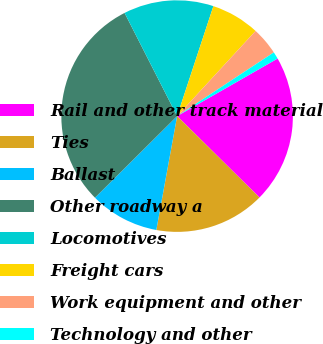<chart> <loc_0><loc_0><loc_500><loc_500><pie_chart><fcel>Rail and other track material<fcel>Ties<fcel>Ballast<fcel>Other roadway a<fcel>Locomotives<fcel>Freight cars<fcel>Work equipment and other<fcel>Technology and other<nl><fcel>20.69%<fcel>15.47%<fcel>9.68%<fcel>29.95%<fcel>12.57%<fcel>6.78%<fcel>3.88%<fcel>0.99%<nl></chart> 